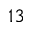Convert formula to latex. <formula><loc_0><loc_0><loc_500><loc_500>^ { 1 3 }</formula> 